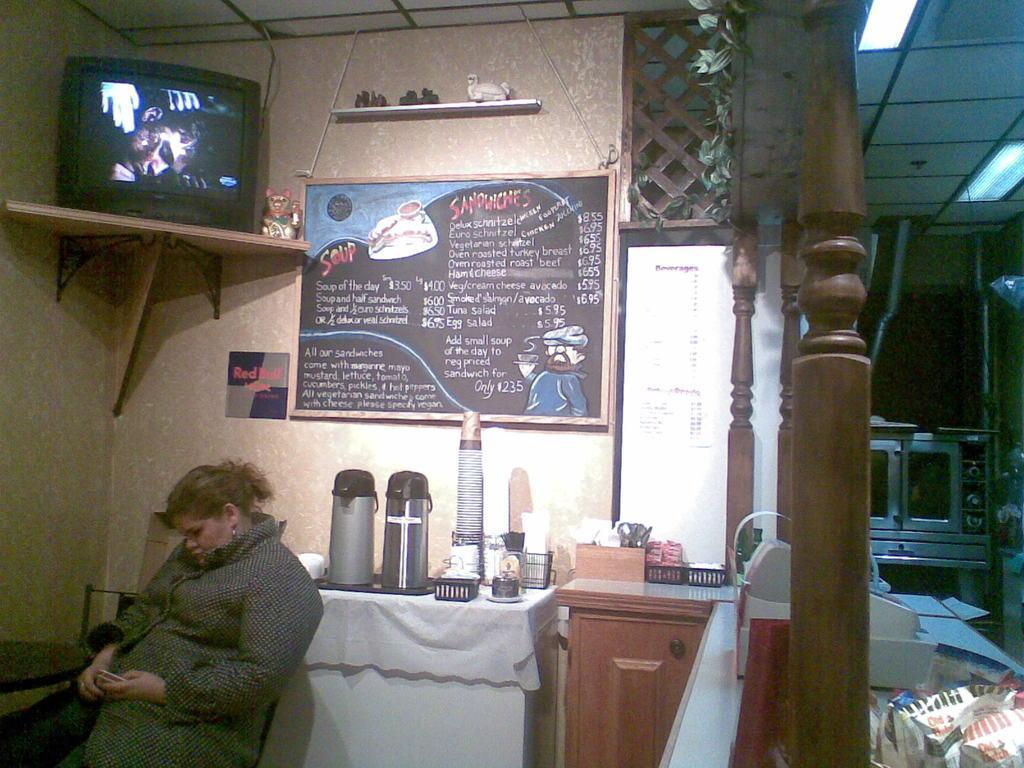How would you summarize this image in a sentence or two? There is a woman sitting and there is a board with menu and there is a TV on top. 